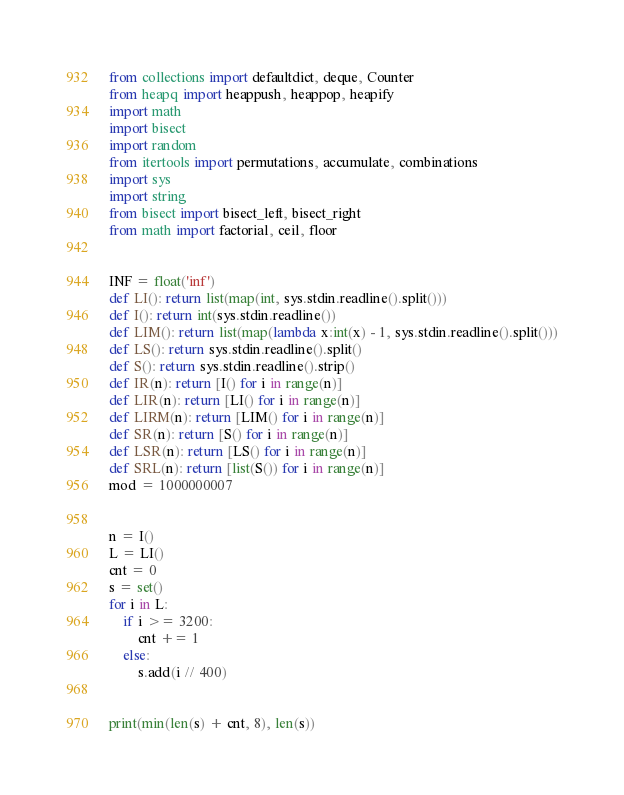Convert code to text. <code><loc_0><loc_0><loc_500><loc_500><_Python_>from collections import defaultdict, deque, Counter
from heapq import heappush, heappop, heapify
import math
import bisect
import random
from itertools import permutations, accumulate, combinations
import sys
import string
from bisect import bisect_left, bisect_right
from math import factorial, ceil, floor


INF = float('inf')
def LI(): return list(map(int, sys.stdin.readline().split()))
def I(): return int(sys.stdin.readline())
def LIM(): return list(map(lambda x:int(x) - 1, sys.stdin.readline().split()))
def LS(): return sys.stdin.readline().split()
def S(): return sys.stdin.readline().strip()
def IR(n): return [I() for i in range(n)]
def LIR(n): return [LI() for i in range(n)]
def LIRM(n): return [LIM() for i in range(n)]
def SR(n): return [S() for i in range(n)]
def LSR(n): return [LS() for i in range(n)]
def SRL(n): return [list(S()) for i in range(n)]
mod = 1000000007


n = I()
L = LI()
cnt = 0
s = set()
for i in L:
    if i >= 3200:
        cnt += 1
    else:
        s.add(i // 400)


print(min(len(s) + cnt, 8), len(s))</code> 